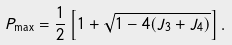<formula> <loc_0><loc_0><loc_500><loc_500>P _ { \max } = \frac { 1 } { 2 } \left [ 1 + \sqrt { 1 - 4 ( J _ { 3 } + J _ { 4 } ) } \right ] .</formula> 